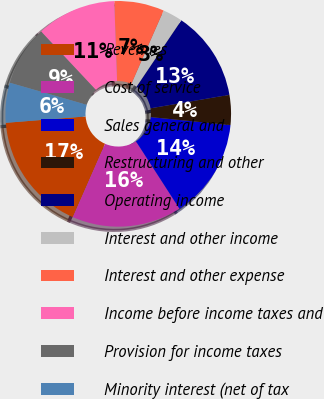Convert chart. <chart><loc_0><loc_0><loc_500><loc_500><pie_chart><fcel>Revenues<fcel>Cost of service<fcel>Sales general and<fcel>Restructuring and other<fcel>Operating income<fcel>Interest and other income<fcel>Interest and other expense<fcel>Income before income taxes and<fcel>Provision for income taxes<fcel>Minority interest (net of tax<nl><fcel>17.14%<fcel>15.71%<fcel>14.29%<fcel>4.29%<fcel>12.86%<fcel>2.86%<fcel>7.14%<fcel>11.43%<fcel>8.57%<fcel>5.71%<nl></chart> 